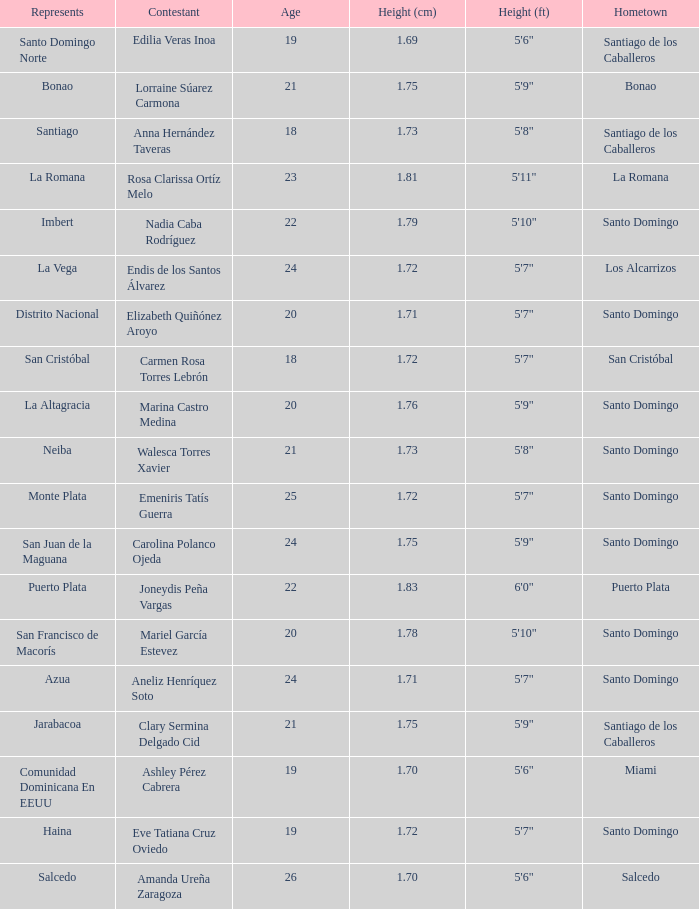Name the most age 26.0. 